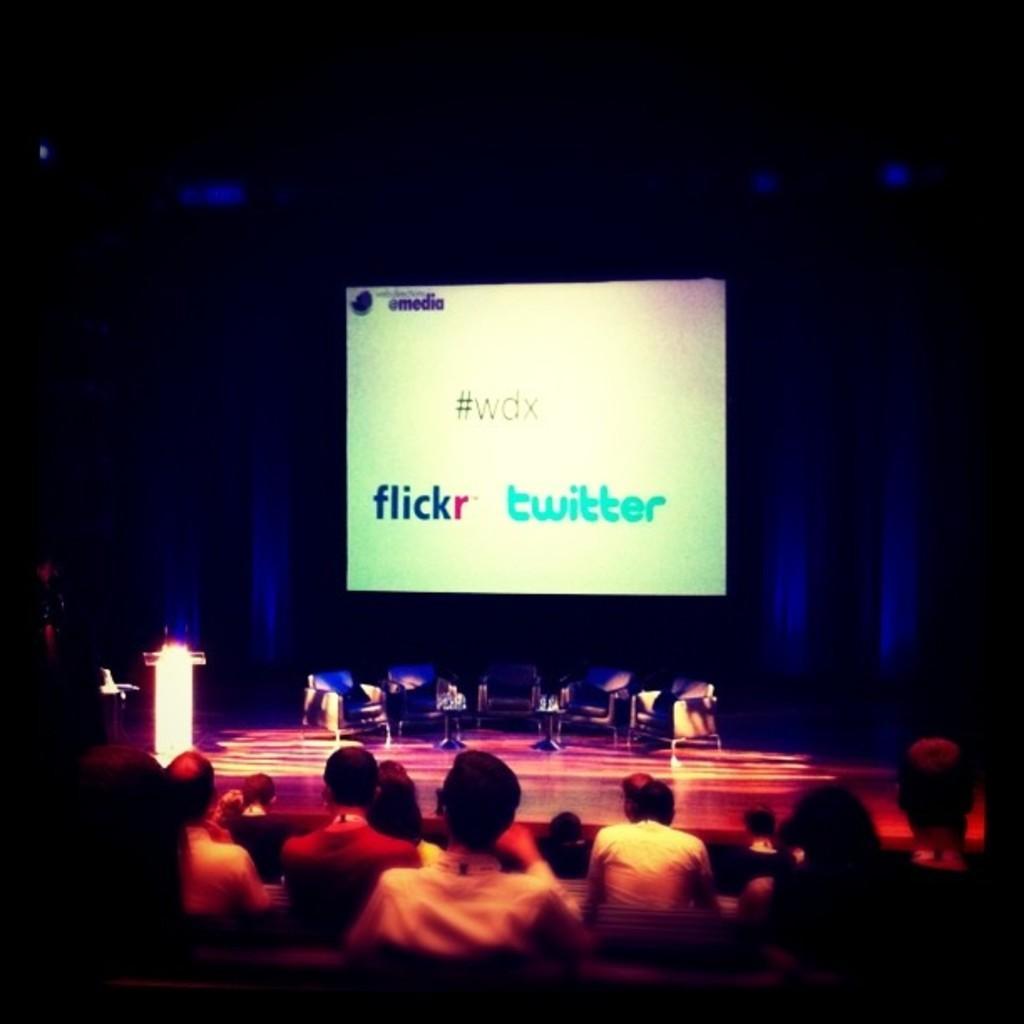Describe this image in one or two sentences. In this image we can see chairs and podium on the stage. Behind screen is there. Bottom of the image people are sitting. 